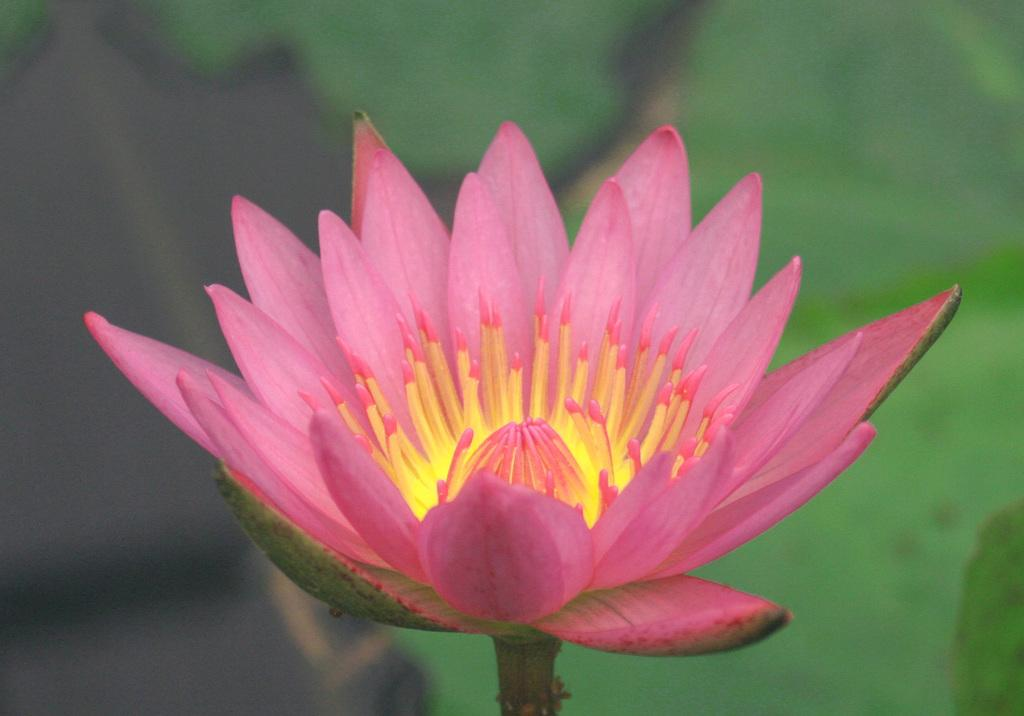What type of flower is present in the image? There is a pink color flower in the image. Can you describe any part of the flower besides its color? The flower has a stem. How does the flower compare to the houses in the image? There are no houses present in the image, so it is not possible to make a comparison. 